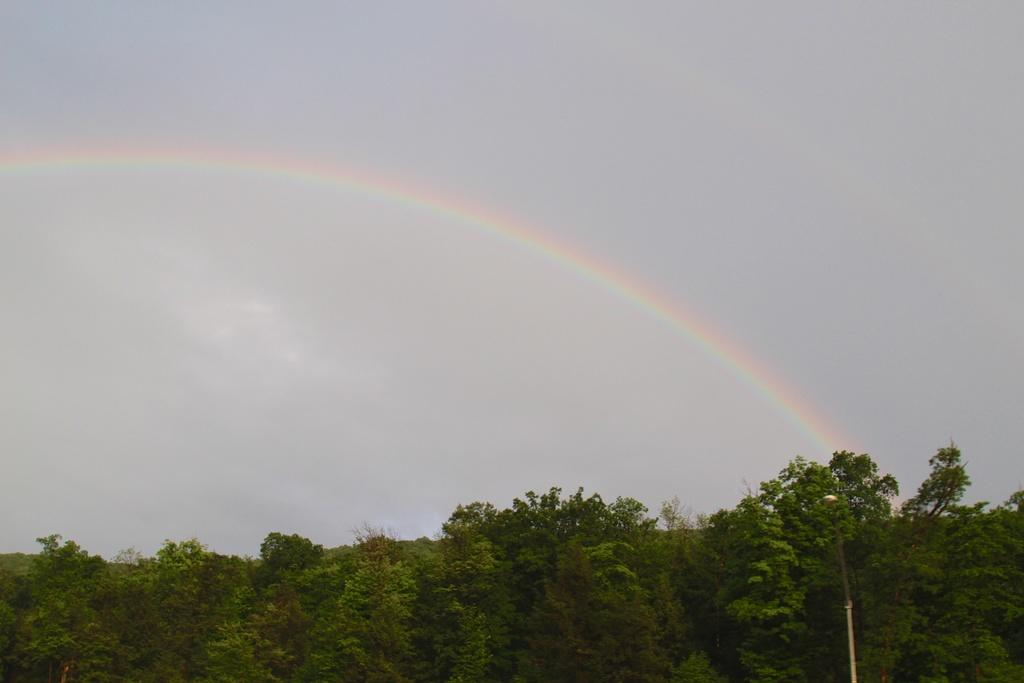What natural phenomenon can be seen in the sky in the image? There is a rainbow in the sky in the image. What type of vegetation is visible at the bottom of the image? Trees are visible at the bottom of the image. What type of chess piece is located on the left side of the image? There is no chess piece present in the image. What reason might the rainbow be appearing in the image? The image does not provide any information about the reason for the rainbow's appearance. 